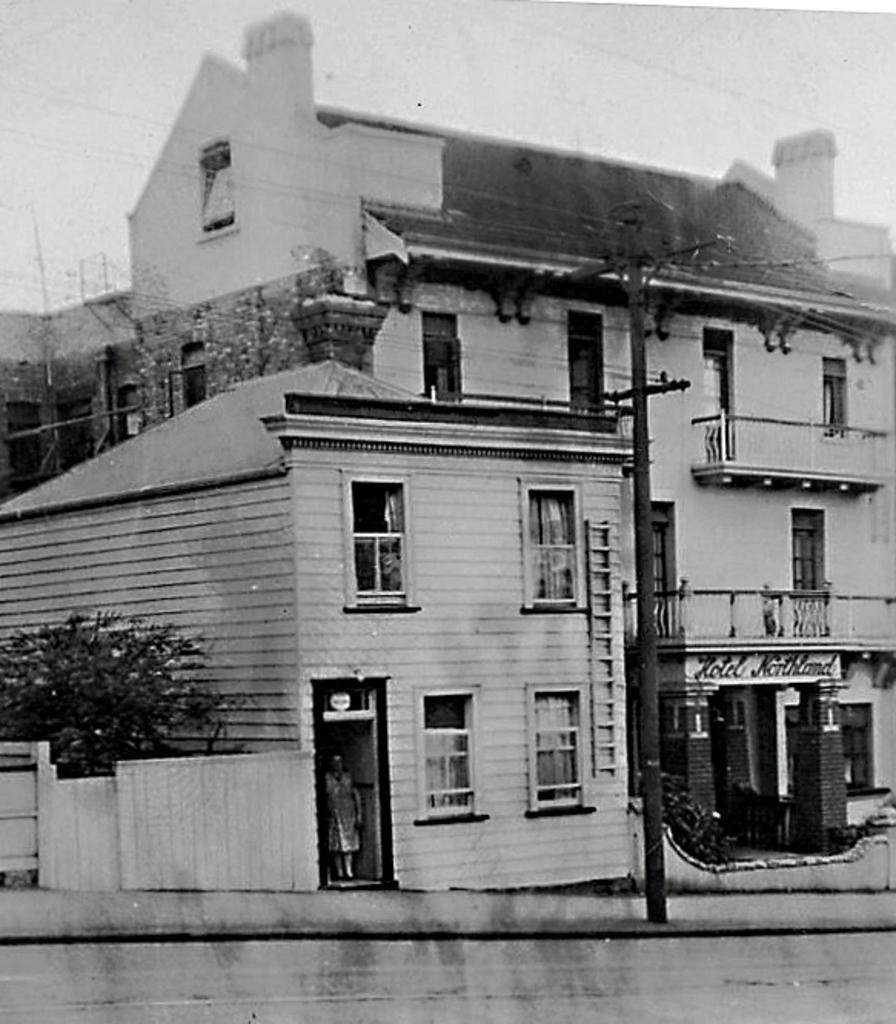How would you summarize this image in a sentence or two? This is a black and white picture. In this picture we can see the road, person, pole, wall, trees and buildings with windows. 